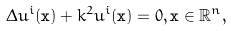Convert formula to latex. <formula><loc_0><loc_0><loc_500><loc_500>\Delta u ^ { i } ( \mathbf x ) + k ^ { 2 } u ^ { i } ( \mathbf x ) = 0 , \mathbf x \in \mathbb { R } ^ { n } ,</formula> 